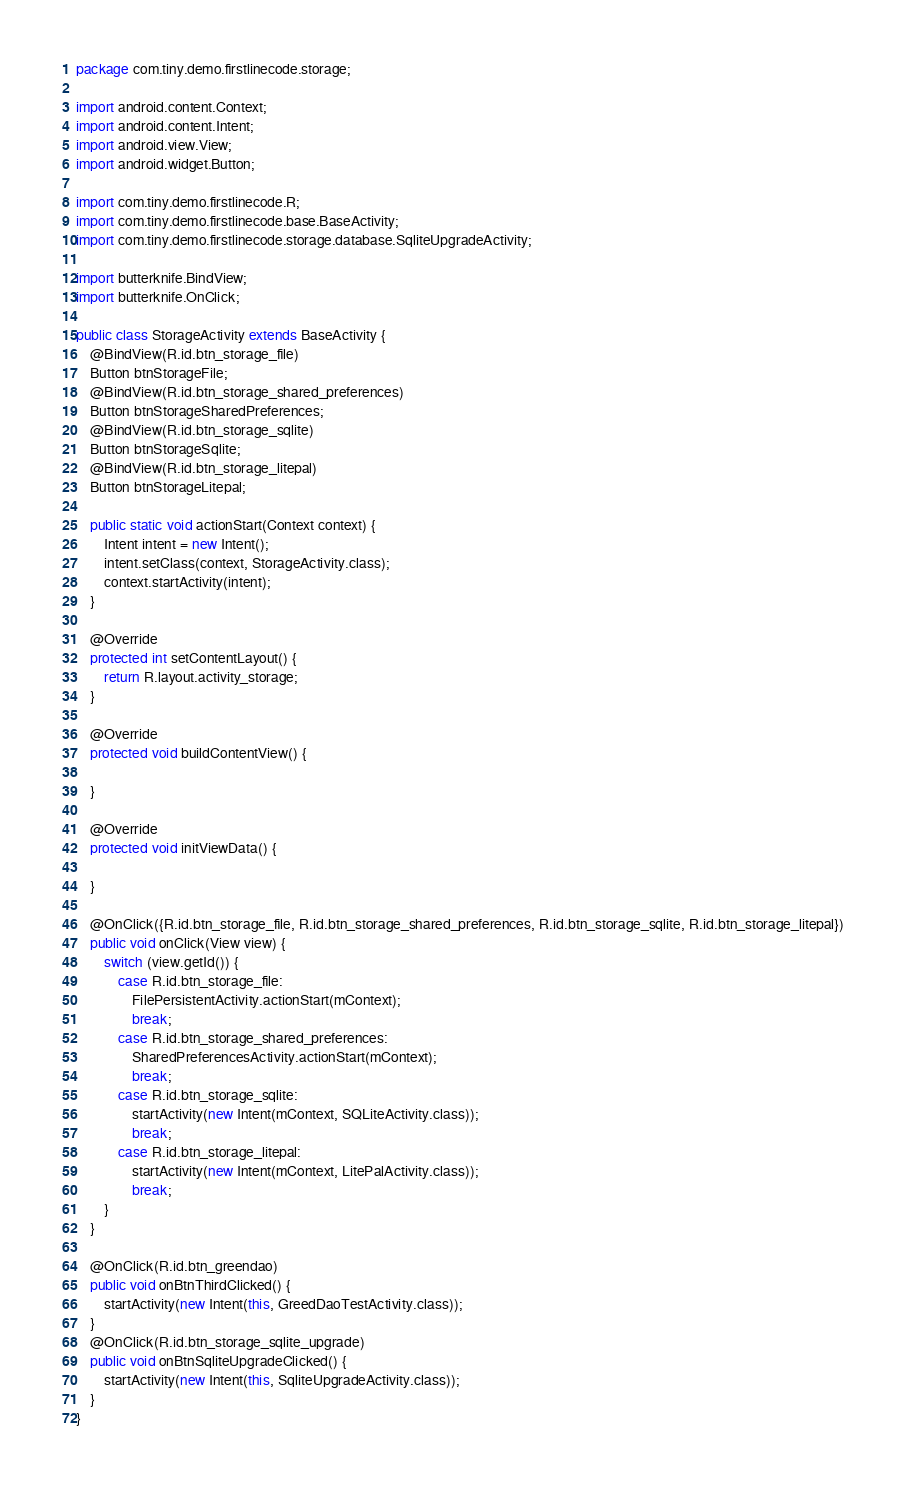<code> <loc_0><loc_0><loc_500><loc_500><_Java_>package com.tiny.demo.firstlinecode.storage;

import android.content.Context;
import android.content.Intent;
import android.view.View;
import android.widget.Button;

import com.tiny.demo.firstlinecode.R;
import com.tiny.demo.firstlinecode.base.BaseActivity;
import com.tiny.demo.firstlinecode.storage.database.SqliteUpgradeActivity;

import butterknife.BindView;
import butterknife.OnClick;

public class StorageActivity extends BaseActivity {
    @BindView(R.id.btn_storage_file)
    Button btnStorageFile;
    @BindView(R.id.btn_storage_shared_preferences)
    Button btnStorageSharedPreferences;
    @BindView(R.id.btn_storage_sqlite)
    Button btnStorageSqlite;
    @BindView(R.id.btn_storage_litepal)
    Button btnStorageLitepal;

    public static void actionStart(Context context) {
        Intent intent = new Intent();
        intent.setClass(context, StorageActivity.class);
        context.startActivity(intent);
    }

    @Override
    protected int setContentLayout() {
        return R.layout.activity_storage;
    }

    @Override
    protected void buildContentView() {

    }

    @Override
    protected void initViewData() {

    }

    @OnClick({R.id.btn_storage_file, R.id.btn_storage_shared_preferences, R.id.btn_storage_sqlite, R.id.btn_storage_litepal})
    public void onClick(View view) {
        switch (view.getId()) {
            case R.id.btn_storage_file:
                FilePersistentActivity.actionStart(mContext);
                break;
            case R.id.btn_storage_shared_preferences:
                SharedPreferencesActivity.actionStart(mContext);
                break;
            case R.id.btn_storage_sqlite:
                startActivity(new Intent(mContext, SQLiteActivity.class));
                break;
            case R.id.btn_storage_litepal:
                startActivity(new Intent(mContext, LitePalActivity.class));
                break;
        }
    }

    @OnClick(R.id.btn_greendao)
    public void onBtnThirdClicked() {
        startActivity(new Intent(this, GreedDaoTestActivity.class));
    }
    @OnClick(R.id.btn_storage_sqlite_upgrade)
    public void onBtnSqliteUpgradeClicked() {
        startActivity(new Intent(this, SqliteUpgradeActivity.class));
    }
}
</code> 